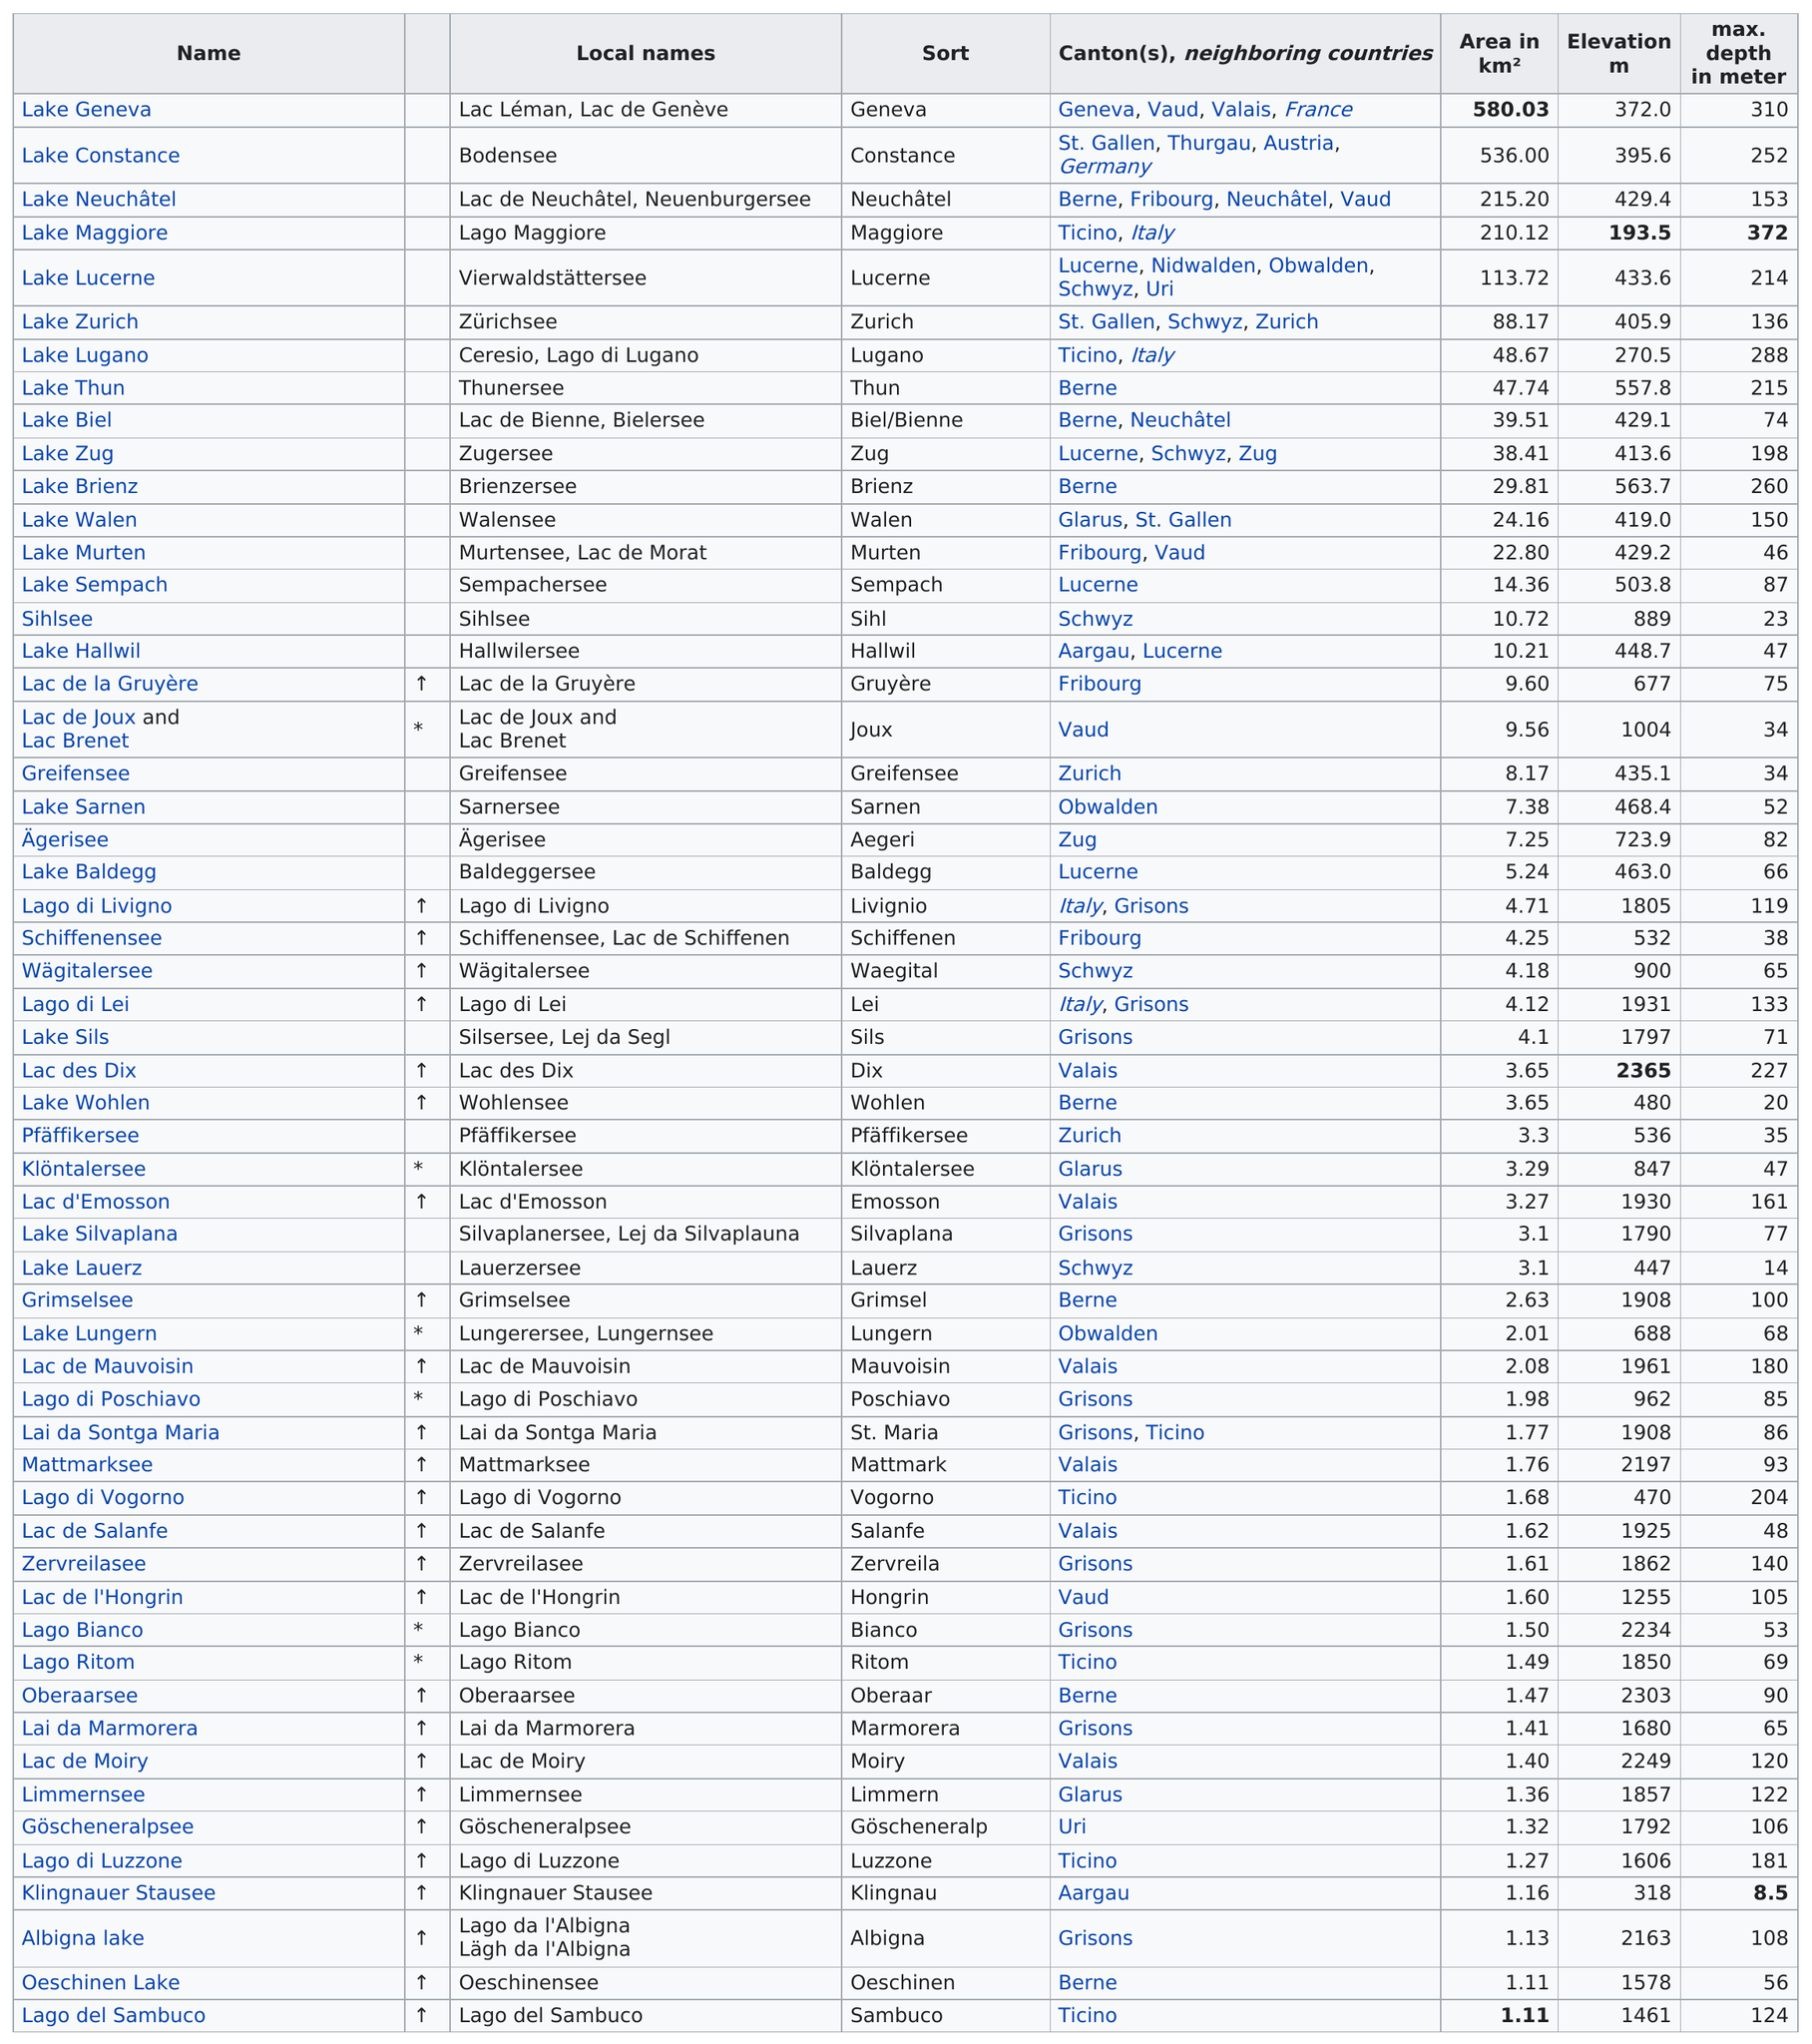Mention a couple of crucial points in this snapshot. Oberaarsee, which is located in the Swiss Alps, has the highest elevation of any lake in the region after Lac des Dix. Lake Maggiore is the lake with the deepest maximum depth. The total area in kilometers squared of Lake Sils is 4.1. Lake Maggiore is the deepest lake in the world. The lake with the highest elevation is Lake Desiree. 